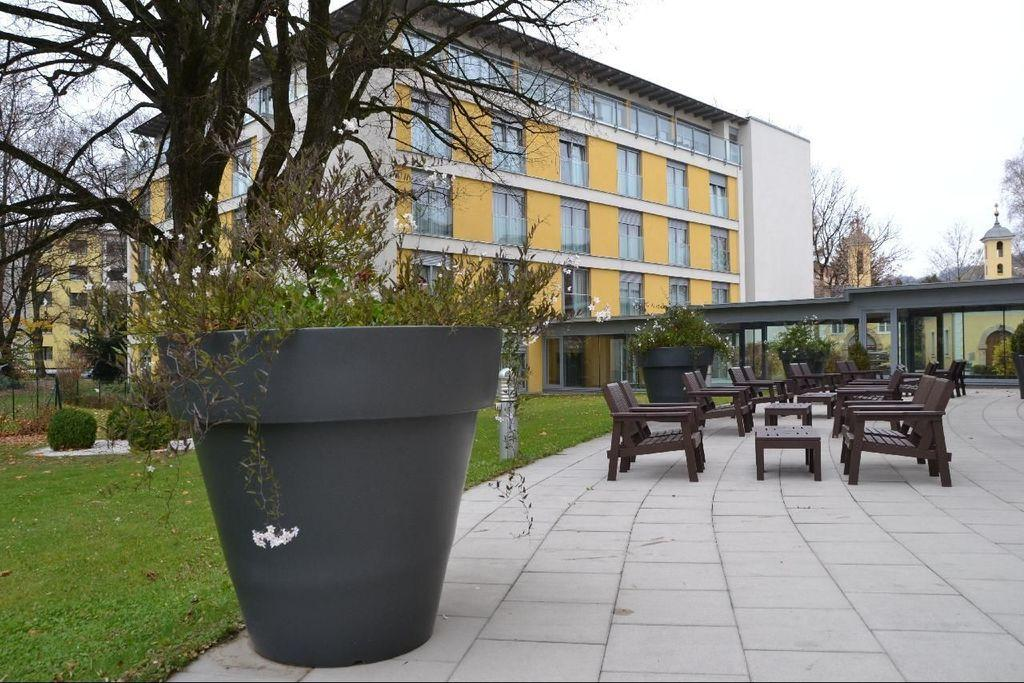What object is present in the image that is used for holding plants? There is a plant pot in the image. Where is the plant pot located? The plant pot is located in a garden. What is the garden situated near in the image? The garden is beside a building. What type of soup is being served in the garden in the image? There is no soup present in the image; it features a plant pot in a garden beside a building. 